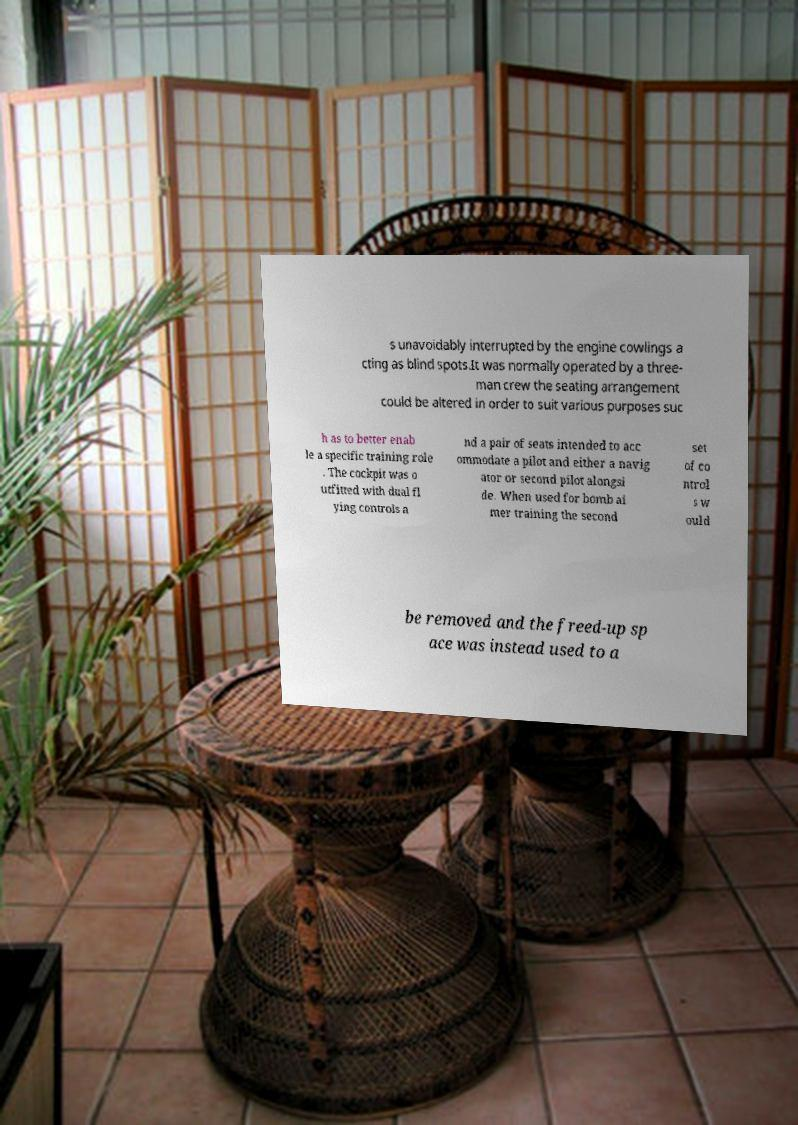Please read and relay the text visible in this image. What does it say? s unavoidably interrupted by the engine cowlings a cting as blind spots.It was normally operated by a three- man crew the seating arrangement could be altered in order to suit various purposes suc h as to better enab le a specific training role . The cockpit was o utfitted with dual fl ying controls a nd a pair of seats intended to acc ommodate a pilot and either a navig ator or second pilot alongsi de. When used for bomb ai mer training the second set of co ntrol s w ould be removed and the freed-up sp ace was instead used to a 